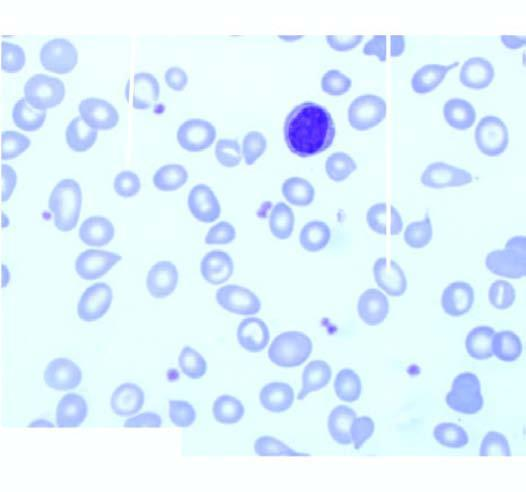what aspirate shows micronormoblastic erythropoiesis?
Answer the question using a single word or phrase. Examination of bone marrow 